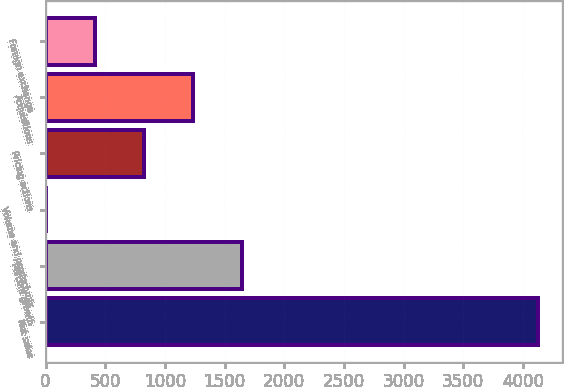Convert chart. <chart><loc_0><loc_0><loc_500><loc_500><bar_chart><fcel>Net sales<fcel>Percent growth<fcel>Volume and product mix<fcel>Pricing actions<fcel>Acquisitions<fcel>Foreign exchange<nl><fcel>4123.4<fcel>1649.42<fcel>0.1<fcel>824.76<fcel>1237.09<fcel>412.43<nl></chart> 